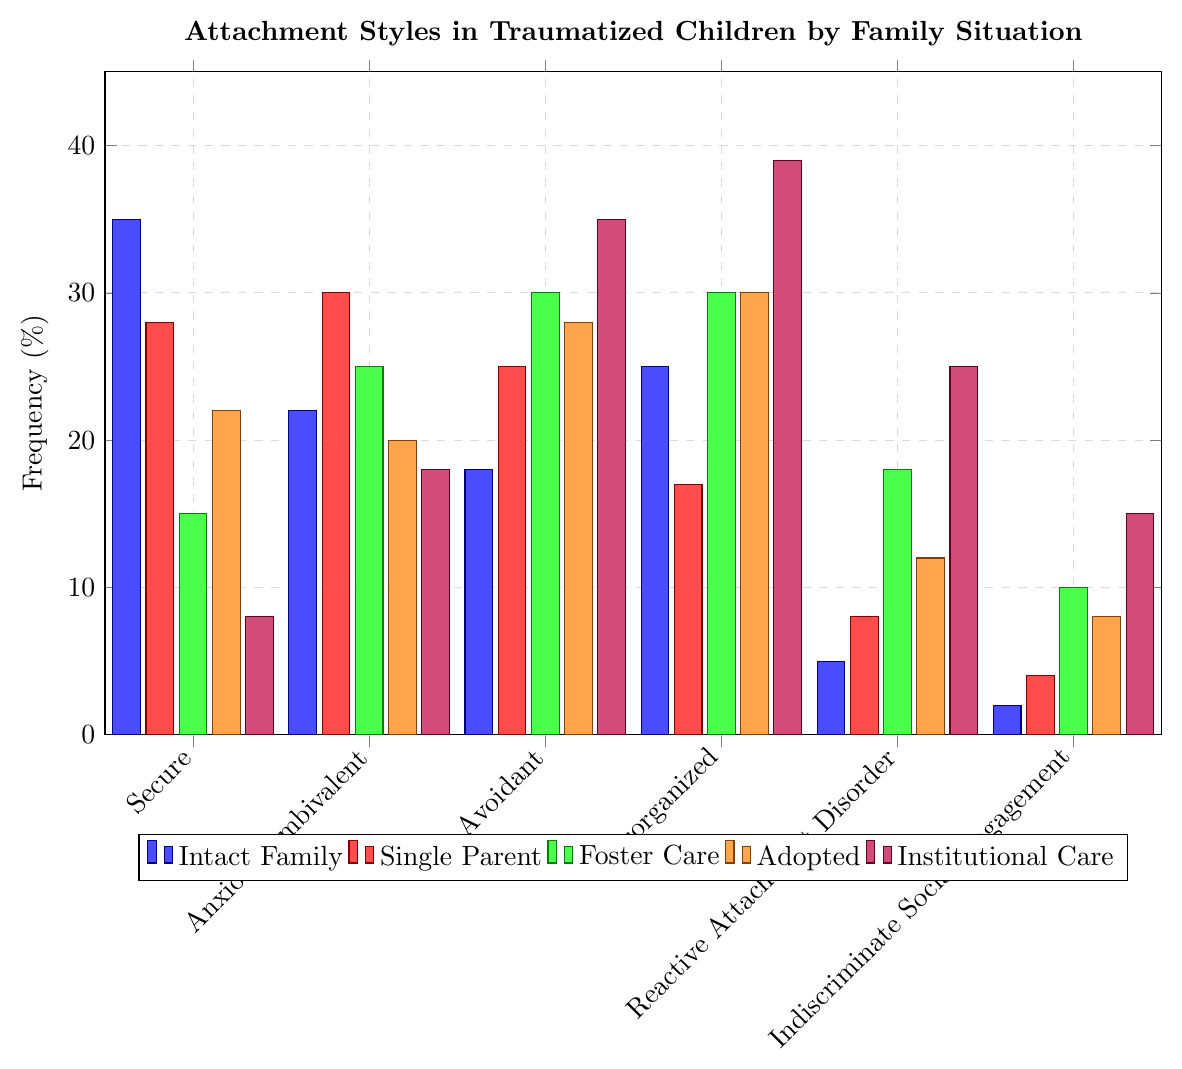What's the most common attachment style among children in institutional care? To find the most common attachment style among children in institutional care, look for the highest bar in purple. The highest bar in purple corresponds to "Disorganized" with a frequency of 39%.
Answer: Disorganized Which family situation has the highest frequency of Secure attachment style? To determine which family situation has the highest frequency of Secure attachment style, compare the heights of the "Secure" bars in all colors. The tallest bar for "Secure" is blue, representing intact families, with a frequency of 35%.
Answer: Intact Family Compare the frequency of Avoidant attachment style between children in foster care and institutional care. Which is higher? Look at the heights of the "Avoidant" bars in green (foster care) and purple (institutional care). The purple bar (35%) is taller than the green bar (30%), indicating a higher frequency in institutional care.
Answer: Institutional Care What is the average frequency of Disorganized attachment for children in single-parent, foster care, and adopted situations? First, find the frequencies: Single Parent (17%), Foster Care (30%), and Adopted (30%). Average these values: (17 + 30 + 30) / 3 = 77 / 3 ≈ 25.67%.
Answer: 25.67% Which attachment style has the lowest frequency in intact families? Locate the smallest bar in blue. The blue bar for "Indiscriminate Social Engagement" is the shortest, with a frequency of 2%.
Answer: Indiscriminate Social Engagement What is the total frequency of Reactive Attachment Disorder in single-parent and adopted situations? Add the frequencies of Reactive Attachment Disorder in single-parent (8%) and adopted (12%) families. 8 + 12 = 20%.
Answer: 20% Which family situation shows the least variation in attachment styles? Check the range of frequencies for each family situation's bars. The smallest range is in the "Single Parent" situation, where frequencies vary less (4%-30%), compared to other family situations.
Answer: Single Parent 